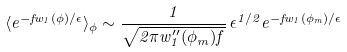Convert formula to latex. <formula><loc_0><loc_0><loc_500><loc_500>\langle e ^ { - f w _ { 1 } ( \phi ) / \epsilon } \rangle _ { \phi } \sim \frac { 1 } { \sqrt { 2 \pi w ^ { \prime \prime } _ { 1 } ( \phi _ { m } ) f } } \, { \epsilon } ^ { 1 / 2 } e ^ { - f w _ { 1 } ( \phi _ { m } ) / \epsilon }</formula> 